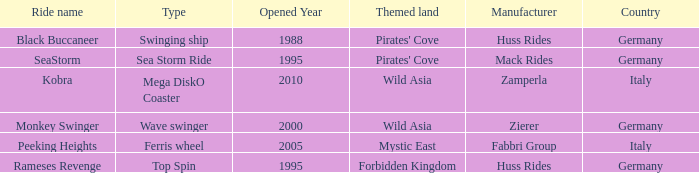What type ride is Wild Asia that opened in 2000? Wave swinger. 